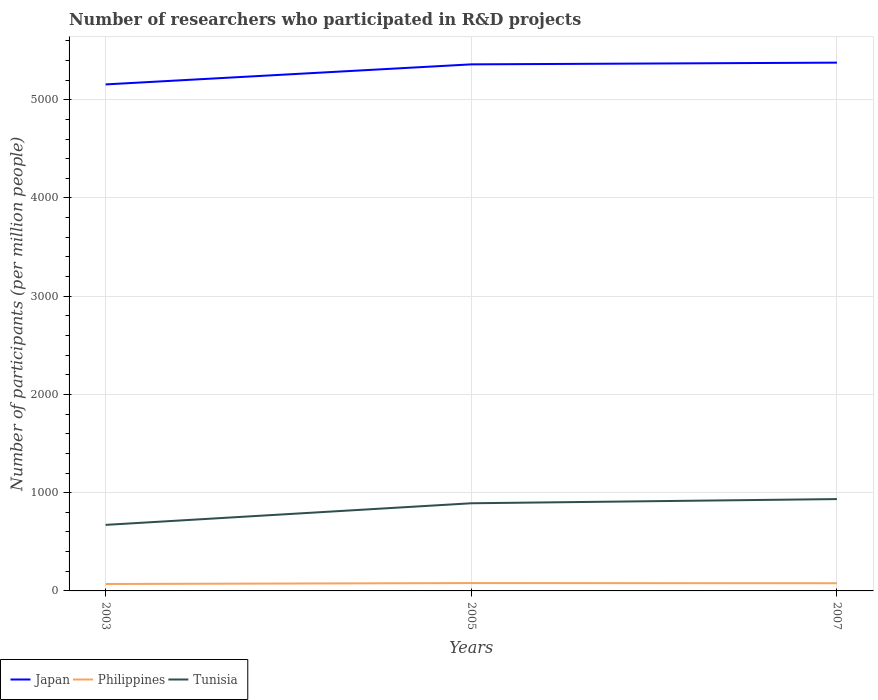Across all years, what is the maximum number of researchers who participated in R&D projects in Japan?
Provide a short and direct response. 5156.09. In which year was the number of researchers who participated in R&D projects in Japan maximum?
Provide a short and direct response. 2003. What is the total number of researchers who participated in R&D projects in Tunisia in the graph?
Provide a succinct answer. -42.62. What is the difference between the highest and the second highest number of researchers who participated in R&D projects in Tunisia?
Offer a very short reply. 262.6. How many years are there in the graph?
Provide a short and direct response. 3. What is the difference between two consecutive major ticks on the Y-axis?
Your answer should be very brief. 1000. Are the values on the major ticks of Y-axis written in scientific E-notation?
Provide a succinct answer. No. Does the graph contain any zero values?
Make the answer very short. No. How many legend labels are there?
Provide a short and direct response. 3. How are the legend labels stacked?
Offer a terse response. Horizontal. What is the title of the graph?
Offer a very short reply. Number of researchers who participated in R&D projects. What is the label or title of the X-axis?
Your answer should be very brief. Years. What is the label or title of the Y-axis?
Give a very brief answer. Number of participants (per million people). What is the Number of participants (per million people) of Japan in 2003?
Make the answer very short. 5156.09. What is the Number of participants (per million people) of Philippines in 2003?
Make the answer very short. 70.63. What is the Number of participants (per million people) in Tunisia in 2003?
Ensure brevity in your answer.  672.37. What is the Number of participants (per million people) of Japan in 2005?
Provide a succinct answer. 5360.2. What is the Number of participants (per million people) in Philippines in 2005?
Make the answer very short. 80.05. What is the Number of participants (per million people) in Tunisia in 2005?
Ensure brevity in your answer.  892.36. What is the Number of participants (per million people) in Japan in 2007?
Your response must be concise. 5377.69. What is the Number of participants (per million people) of Philippines in 2007?
Make the answer very short. 78.2. What is the Number of participants (per million people) of Tunisia in 2007?
Ensure brevity in your answer.  934.97. Across all years, what is the maximum Number of participants (per million people) of Japan?
Make the answer very short. 5377.69. Across all years, what is the maximum Number of participants (per million people) in Philippines?
Give a very brief answer. 80.05. Across all years, what is the maximum Number of participants (per million people) in Tunisia?
Your answer should be compact. 934.97. Across all years, what is the minimum Number of participants (per million people) in Japan?
Your answer should be compact. 5156.09. Across all years, what is the minimum Number of participants (per million people) in Philippines?
Offer a very short reply. 70.63. Across all years, what is the minimum Number of participants (per million people) in Tunisia?
Give a very brief answer. 672.37. What is the total Number of participants (per million people) in Japan in the graph?
Provide a short and direct response. 1.59e+04. What is the total Number of participants (per million people) in Philippines in the graph?
Keep it short and to the point. 228.88. What is the total Number of participants (per million people) in Tunisia in the graph?
Keep it short and to the point. 2499.7. What is the difference between the Number of participants (per million people) in Japan in 2003 and that in 2005?
Ensure brevity in your answer.  -204.1. What is the difference between the Number of participants (per million people) in Philippines in 2003 and that in 2005?
Give a very brief answer. -9.43. What is the difference between the Number of participants (per million people) of Tunisia in 2003 and that in 2005?
Offer a terse response. -219.99. What is the difference between the Number of participants (per million people) in Japan in 2003 and that in 2007?
Make the answer very short. -221.6. What is the difference between the Number of participants (per million people) in Philippines in 2003 and that in 2007?
Give a very brief answer. -7.57. What is the difference between the Number of participants (per million people) in Tunisia in 2003 and that in 2007?
Make the answer very short. -262.6. What is the difference between the Number of participants (per million people) of Japan in 2005 and that in 2007?
Provide a short and direct response. -17.49. What is the difference between the Number of participants (per million people) of Philippines in 2005 and that in 2007?
Your response must be concise. 1.86. What is the difference between the Number of participants (per million people) in Tunisia in 2005 and that in 2007?
Ensure brevity in your answer.  -42.62. What is the difference between the Number of participants (per million people) in Japan in 2003 and the Number of participants (per million people) in Philippines in 2005?
Offer a terse response. 5076.04. What is the difference between the Number of participants (per million people) of Japan in 2003 and the Number of participants (per million people) of Tunisia in 2005?
Provide a short and direct response. 4263.74. What is the difference between the Number of participants (per million people) in Philippines in 2003 and the Number of participants (per million people) in Tunisia in 2005?
Your response must be concise. -821.73. What is the difference between the Number of participants (per million people) in Japan in 2003 and the Number of participants (per million people) in Philippines in 2007?
Your answer should be compact. 5077.89. What is the difference between the Number of participants (per million people) in Japan in 2003 and the Number of participants (per million people) in Tunisia in 2007?
Offer a very short reply. 4221.12. What is the difference between the Number of participants (per million people) in Philippines in 2003 and the Number of participants (per million people) in Tunisia in 2007?
Ensure brevity in your answer.  -864.34. What is the difference between the Number of participants (per million people) in Japan in 2005 and the Number of participants (per million people) in Philippines in 2007?
Offer a terse response. 5282. What is the difference between the Number of participants (per million people) of Japan in 2005 and the Number of participants (per million people) of Tunisia in 2007?
Ensure brevity in your answer.  4425.23. What is the difference between the Number of participants (per million people) of Philippines in 2005 and the Number of participants (per million people) of Tunisia in 2007?
Give a very brief answer. -854.92. What is the average Number of participants (per million people) of Japan per year?
Ensure brevity in your answer.  5297.99. What is the average Number of participants (per million people) in Philippines per year?
Your answer should be very brief. 76.29. What is the average Number of participants (per million people) of Tunisia per year?
Provide a succinct answer. 833.23. In the year 2003, what is the difference between the Number of participants (per million people) in Japan and Number of participants (per million people) in Philippines?
Offer a very short reply. 5085.47. In the year 2003, what is the difference between the Number of participants (per million people) in Japan and Number of participants (per million people) in Tunisia?
Make the answer very short. 4483.72. In the year 2003, what is the difference between the Number of participants (per million people) of Philippines and Number of participants (per million people) of Tunisia?
Offer a very short reply. -601.74. In the year 2005, what is the difference between the Number of participants (per million people) in Japan and Number of participants (per million people) in Philippines?
Offer a very short reply. 5280.14. In the year 2005, what is the difference between the Number of participants (per million people) in Japan and Number of participants (per million people) in Tunisia?
Offer a very short reply. 4467.84. In the year 2005, what is the difference between the Number of participants (per million people) in Philippines and Number of participants (per million people) in Tunisia?
Offer a very short reply. -812.3. In the year 2007, what is the difference between the Number of participants (per million people) in Japan and Number of participants (per million people) in Philippines?
Provide a succinct answer. 5299.49. In the year 2007, what is the difference between the Number of participants (per million people) of Japan and Number of participants (per million people) of Tunisia?
Give a very brief answer. 4442.72. In the year 2007, what is the difference between the Number of participants (per million people) in Philippines and Number of participants (per million people) in Tunisia?
Give a very brief answer. -856.77. What is the ratio of the Number of participants (per million people) in Japan in 2003 to that in 2005?
Provide a short and direct response. 0.96. What is the ratio of the Number of participants (per million people) in Philippines in 2003 to that in 2005?
Your response must be concise. 0.88. What is the ratio of the Number of participants (per million people) of Tunisia in 2003 to that in 2005?
Provide a short and direct response. 0.75. What is the ratio of the Number of participants (per million people) in Japan in 2003 to that in 2007?
Make the answer very short. 0.96. What is the ratio of the Number of participants (per million people) of Philippines in 2003 to that in 2007?
Provide a short and direct response. 0.9. What is the ratio of the Number of participants (per million people) in Tunisia in 2003 to that in 2007?
Provide a short and direct response. 0.72. What is the ratio of the Number of participants (per million people) in Japan in 2005 to that in 2007?
Your answer should be very brief. 1. What is the ratio of the Number of participants (per million people) in Philippines in 2005 to that in 2007?
Make the answer very short. 1.02. What is the ratio of the Number of participants (per million people) in Tunisia in 2005 to that in 2007?
Offer a terse response. 0.95. What is the difference between the highest and the second highest Number of participants (per million people) in Japan?
Make the answer very short. 17.49. What is the difference between the highest and the second highest Number of participants (per million people) of Philippines?
Give a very brief answer. 1.86. What is the difference between the highest and the second highest Number of participants (per million people) of Tunisia?
Give a very brief answer. 42.62. What is the difference between the highest and the lowest Number of participants (per million people) of Japan?
Your answer should be very brief. 221.6. What is the difference between the highest and the lowest Number of participants (per million people) in Philippines?
Keep it short and to the point. 9.43. What is the difference between the highest and the lowest Number of participants (per million people) of Tunisia?
Offer a terse response. 262.6. 